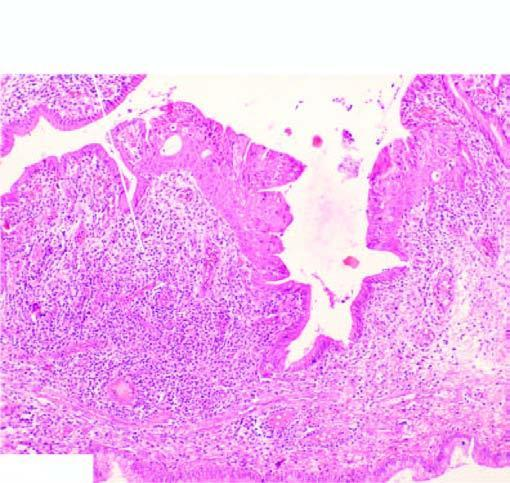what is part of the endocervical mucosa lined by?
Answer the question using a single word or phrase. Normal columnar epithelium 